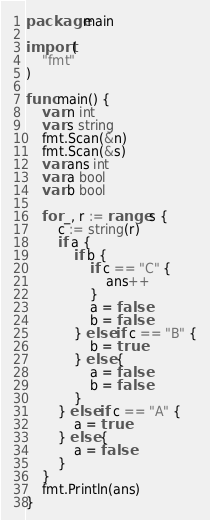Convert code to text. <code><loc_0><loc_0><loc_500><loc_500><_Go_>package main

import (
	"fmt"
)

func main() {
	var n int
	var s string
	fmt.Scan(&n)
	fmt.Scan(&s)
	var ans int
	var a bool
	var b bool

	for _, r := range s {
		c := string(r)
		if a {
			if b {
				if c == "C" {
					ans++
				}
				a = false
				b = false
			} else if c == "B" {
				b = true
			} else {
				a = false
				b = false
			}
		} else if c == "A" {
			a = true
		} else {
			a = false
		}
	}
	fmt.Println(ans)
}
</code> 